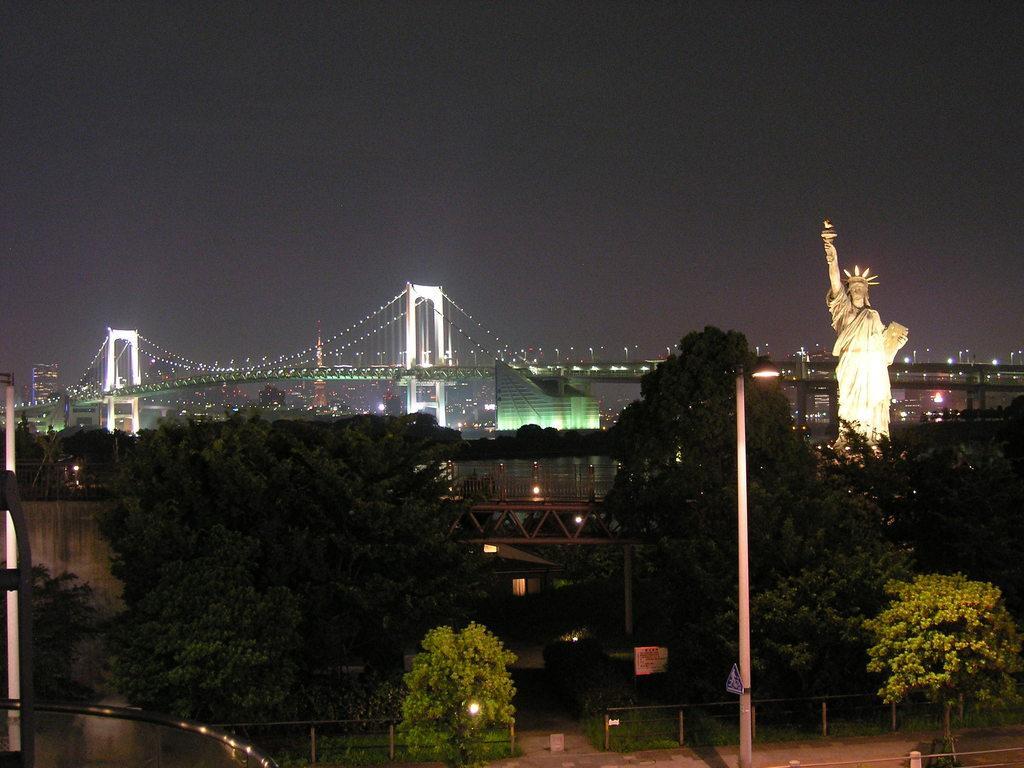Describe this image in one or two sentences. This picture is clicked outside the city. At the bottom of the picture, we see trees and a street light. Behind that, we see a bridge and on the right side, we see the statue of liberty. Behind that, we see a bridge. In the background, we see buildings and street lights. At the top of the picture, we see the sky. This picture is clicked in the dark. 